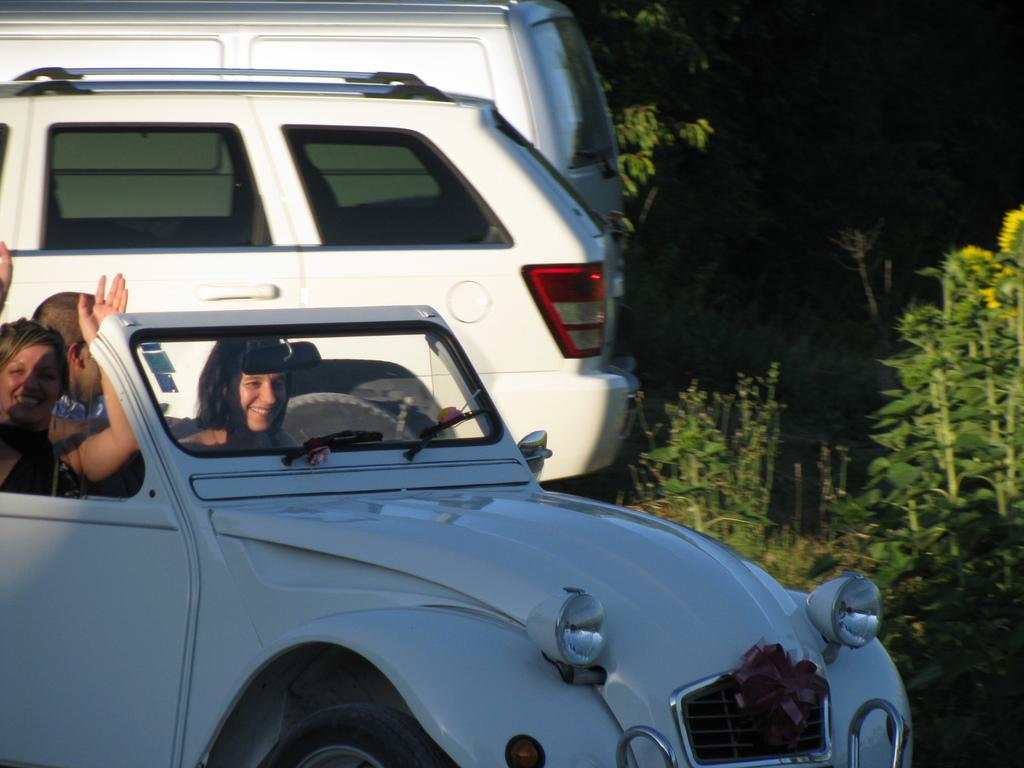What are the people in the image doing? The people in the image are sitting inside a car and smiling. How many cars can be seen in the image? There are three cars in the image, with the first car having people inside and two other cars behind it. What is visible on the right side of the image? There are trees on the right side of the image. How much kitty is present in the image? There is no kitty present in the image. What type of control is being used by the people in the car? The provided facts do not mention any specific control being used by the people in the car. 